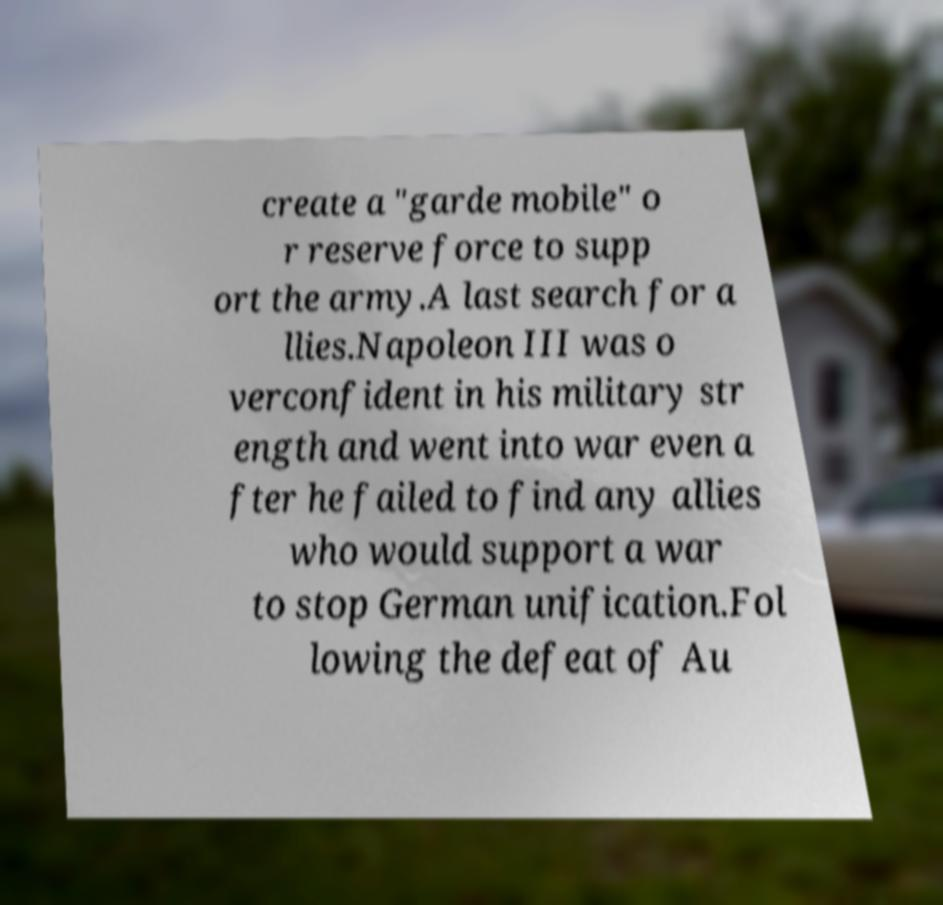For documentation purposes, I need the text within this image transcribed. Could you provide that? create a "garde mobile" o r reserve force to supp ort the army.A last search for a llies.Napoleon III was o verconfident in his military str ength and went into war even a fter he failed to find any allies who would support a war to stop German unification.Fol lowing the defeat of Au 